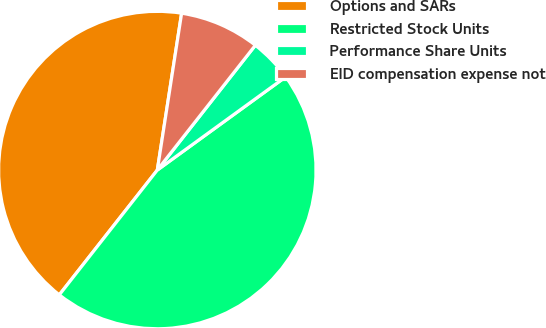Convert chart. <chart><loc_0><loc_0><loc_500><loc_500><pie_chart><fcel>Options and SARs<fcel>Restricted Stock Units<fcel>Performance Share Units<fcel>EID compensation expense not<nl><fcel>41.85%<fcel>45.59%<fcel>4.41%<fcel>8.15%<nl></chart> 